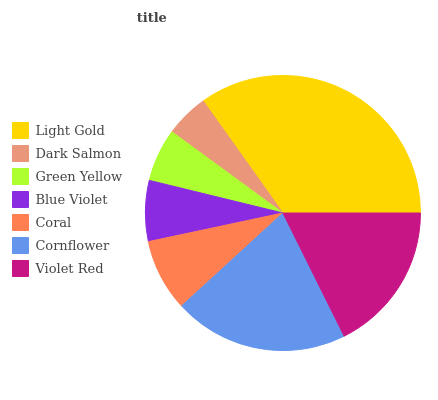Is Dark Salmon the minimum?
Answer yes or no. Yes. Is Light Gold the maximum?
Answer yes or no. Yes. Is Green Yellow the minimum?
Answer yes or no. No. Is Green Yellow the maximum?
Answer yes or no. No. Is Green Yellow greater than Dark Salmon?
Answer yes or no. Yes. Is Dark Salmon less than Green Yellow?
Answer yes or no. Yes. Is Dark Salmon greater than Green Yellow?
Answer yes or no. No. Is Green Yellow less than Dark Salmon?
Answer yes or no. No. Is Coral the high median?
Answer yes or no. Yes. Is Coral the low median?
Answer yes or no. Yes. Is Cornflower the high median?
Answer yes or no. No. Is Green Yellow the low median?
Answer yes or no. No. 